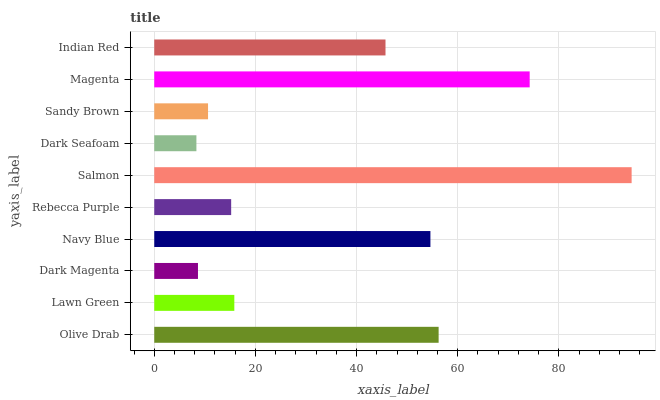Is Dark Seafoam the minimum?
Answer yes or no. Yes. Is Salmon the maximum?
Answer yes or no. Yes. Is Lawn Green the minimum?
Answer yes or no. No. Is Lawn Green the maximum?
Answer yes or no. No. Is Olive Drab greater than Lawn Green?
Answer yes or no. Yes. Is Lawn Green less than Olive Drab?
Answer yes or no. Yes. Is Lawn Green greater than Olive Drab?
Answer yes or no. No. Is Olive Drab less than Lawn Green?
Answer yes or no. No. Is Indian Red the high median?
Answer yes or no. Yes. Is Lawn Green the low median?
Answer yes or no. Yes. Is Rebecca Purple the high median?
Answer yes or no. No. Is Indian Red the low median?
Answer yes or no. No. 